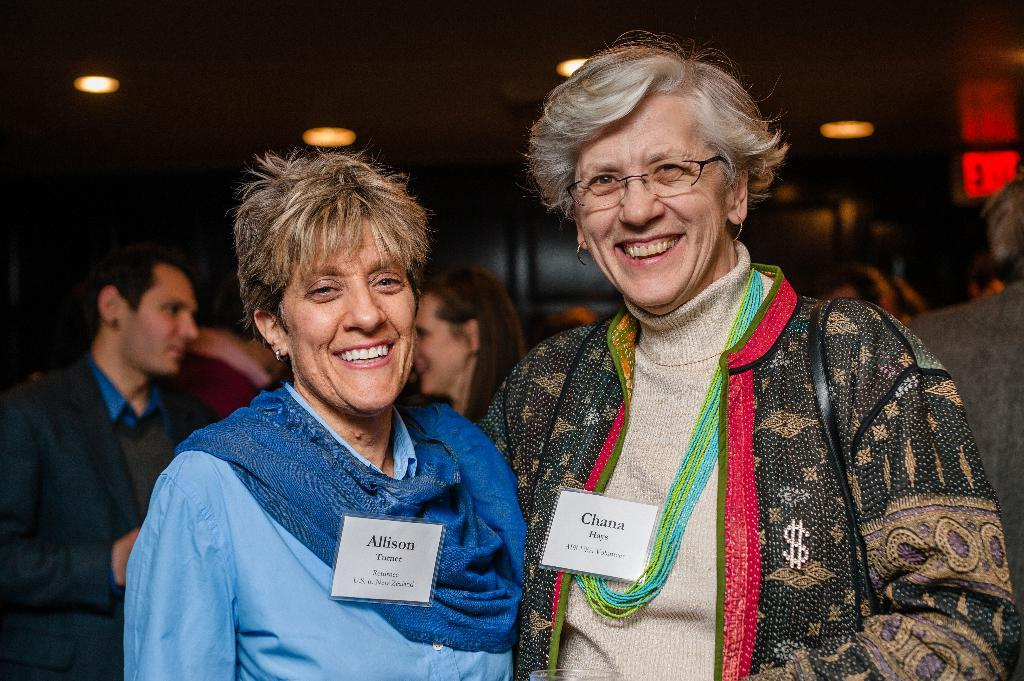How many people are in the image? There are two people in the image. What is the facial expression of the people in the image? The two people are smiling. What can be seen in the background of the image? There are groups of people standing on a path in the background. What type of lighting is present in the image? There are ceiling lights visible in the image. Can you see a bird kicking a soccer ball in the image? No, there is no bird or soccer ball present in the image. 